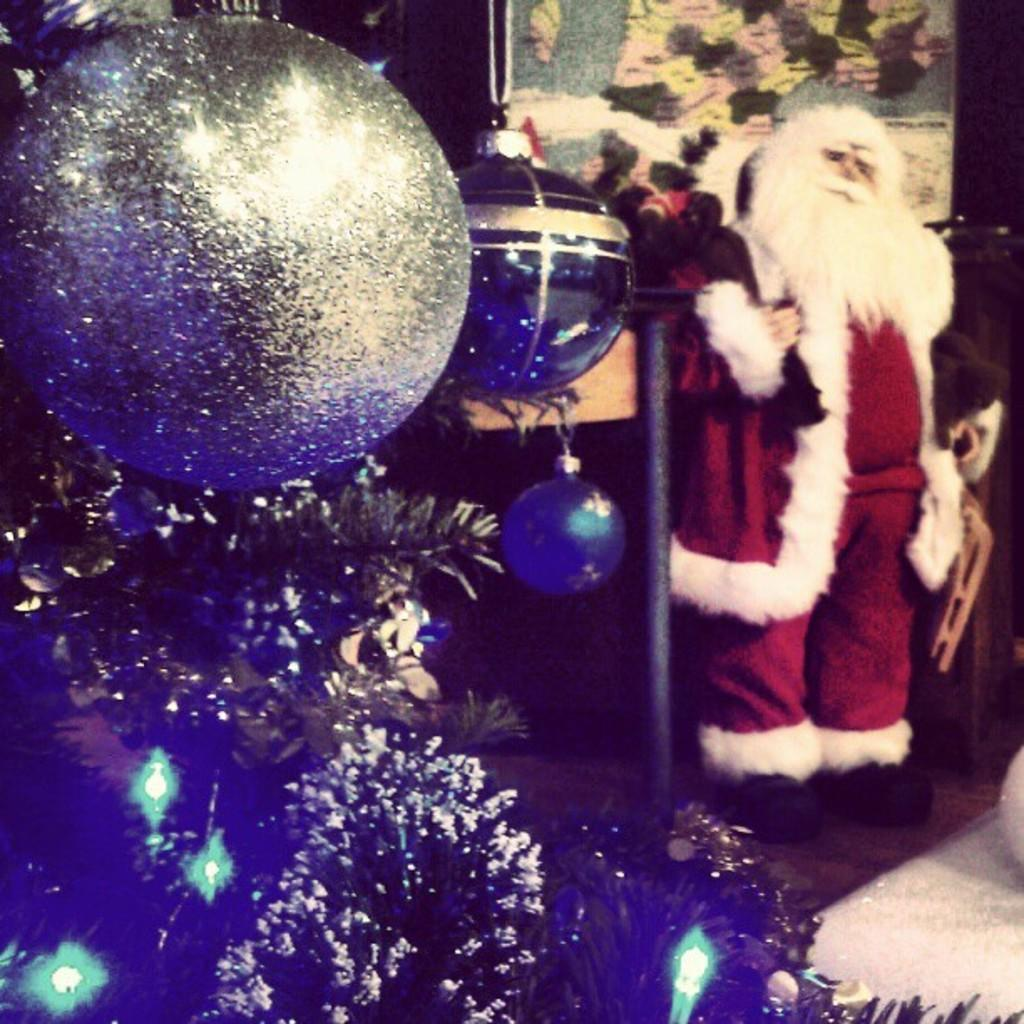What is the main subject of the image? There is a doll in the image. What is the doll wearing? The doll is wearing a red and white costume. What is another object present in the image? There is a Christmas tree in the image. Are there any other decorative elements in the image? Yes, there are decorative items in the image. How many eggs are being used as payment for the boats in the image? There are no eggs, payment, or boats present in the image. 